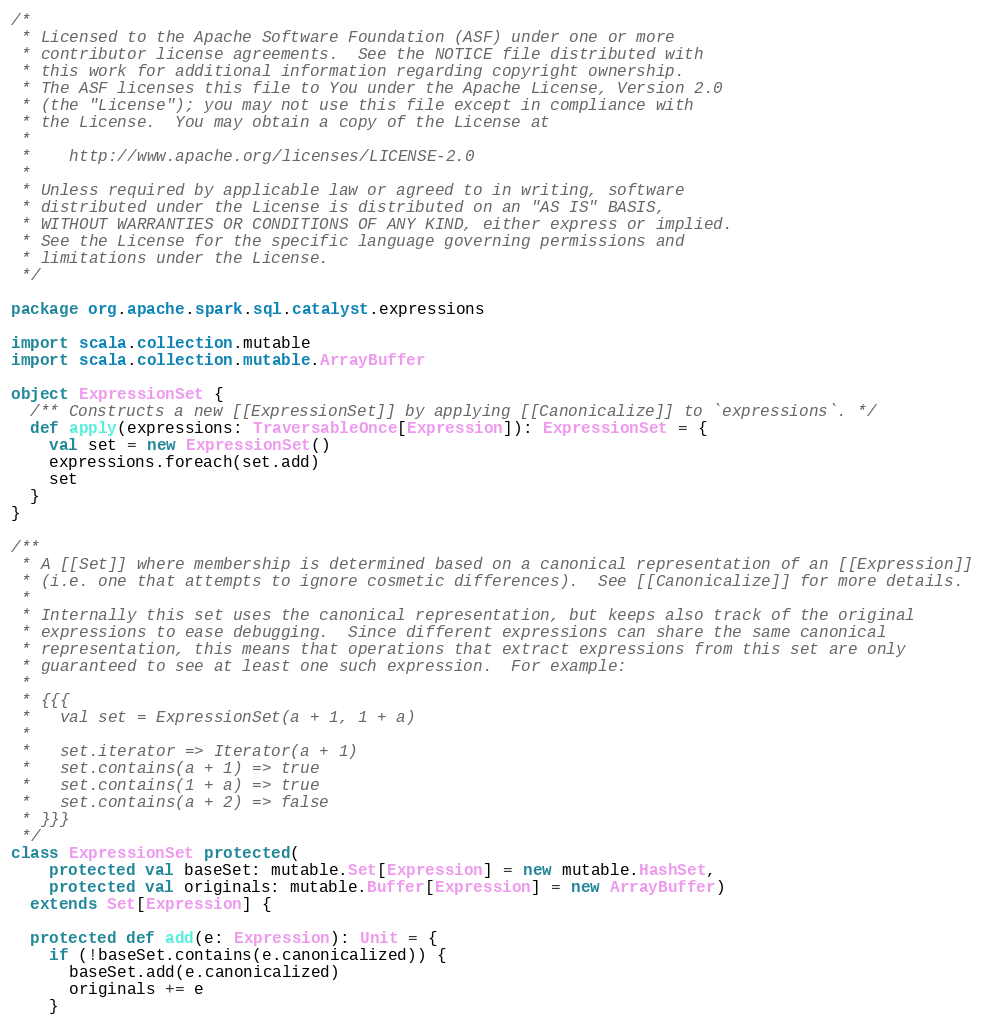Convert code to text. <code><loc_0><loc_0><loc_500><loc_500><_Scala_>/*
 * Licensed to the Apache Software Foundation (ASF) under one or more
 * contributor license agreements.  See the NOTICE file distributed with
 * this work for additional information regarding copyright ownership.
 * The ASF licenses this file to You under the Apache License, Version 2.0
 * (the "License"); you may not use this file except in compliance with
 * the License.  You may obtain a copy of the License at
 *
 *    http://www.apache.org/licenses/LICENSE-2.0
 *
 * Unless required by applicable law or agreed to in writing, software
 * distributed under the License is distributed on an "AS IS" BASIS,
 * WITHOUT WARRANTIES OR CONDITIONS OF ANY KIND, either express or implied.
 * See the License for the specific language governing permissions and
 * limitations under the License.
 */

package org.apache.spark.sql.catalyst.expressions

import scala.collection.mutable
import scala.collection.mutable.ArrayBuffer

object ExpressionSet {
  /** Constructs a new [[ExpressionSet]] by applying [[Canonicalize]] to `expressions`. */
  def apply(expressions: TraversableOnce[Expression]): ExpressionSet = {
    val set = new ExpressionSet()
    expressions.foreach(set.add)
    set
  }
}

/**
 * A [[Set]] where membership is determined based on a canonical representation of an [[Expression]]
 * (i.e. one that attempts to ignore cosmetic differences).  See [[Canonicalize]] for more details.
 *
 * Internally this set uses the canonical representation, but keeps also track of the original
 * expressions to ease debugging.  Since different expressions can share the same canonical
 * representation, this means that operations that extract expressions from this set are only
 * guaranteed to see at least one such expression.  For example:
 *
 * {{{
 *   val set = ExpressionSet(a + 1, 1 + a)
 *
 *   set.iterator => Iterator(a + 1)
 *   set.contains(a + 1) => true
 *   set.contains(1 + a) => true
 *   set.contains(a + 2) => false
 * }}}
 */
class ExpressionSet protected(
    protected val baseSet: mutable.Set[Expression] = new mutable.HashSet,
    protected val originals: mutable.Buffer[Expression] = new ArrayBuffer)
  extends Set[Expression] {

  protected def add(e: Expression): Unit = {
    if (!baseSet.contains(e.canonicalized)) {
      baseSet.add(e.canonicalized)
      originals += e
    }</code> 